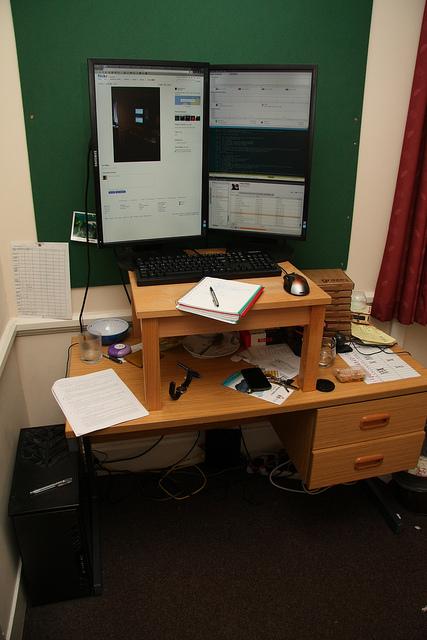What color is the floor?
Be succinct. Brown. What is on top of the binder?
Short answer required. Pen. Where is the mouse?
Keep it brief. Desk. Is there a projector here?
Be succinct. No. What kind of device is on the closest table?
Keep it brief. Computer. How many computer monitors are on the desk?
Be succinct. 2. What is on the ground on the far left?
Be succinct. Computer tower. 